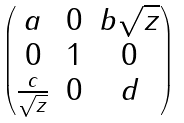<formula> <loc_0><loc_0><loc_500><loc_500>\begin{pmatrix} a & 0 & b \sqrt { z } \\ 0 & 1 & 0 \\ \frac { c } { \sqrt { z } } & 0 & d \end{pmatrix}</formula> 